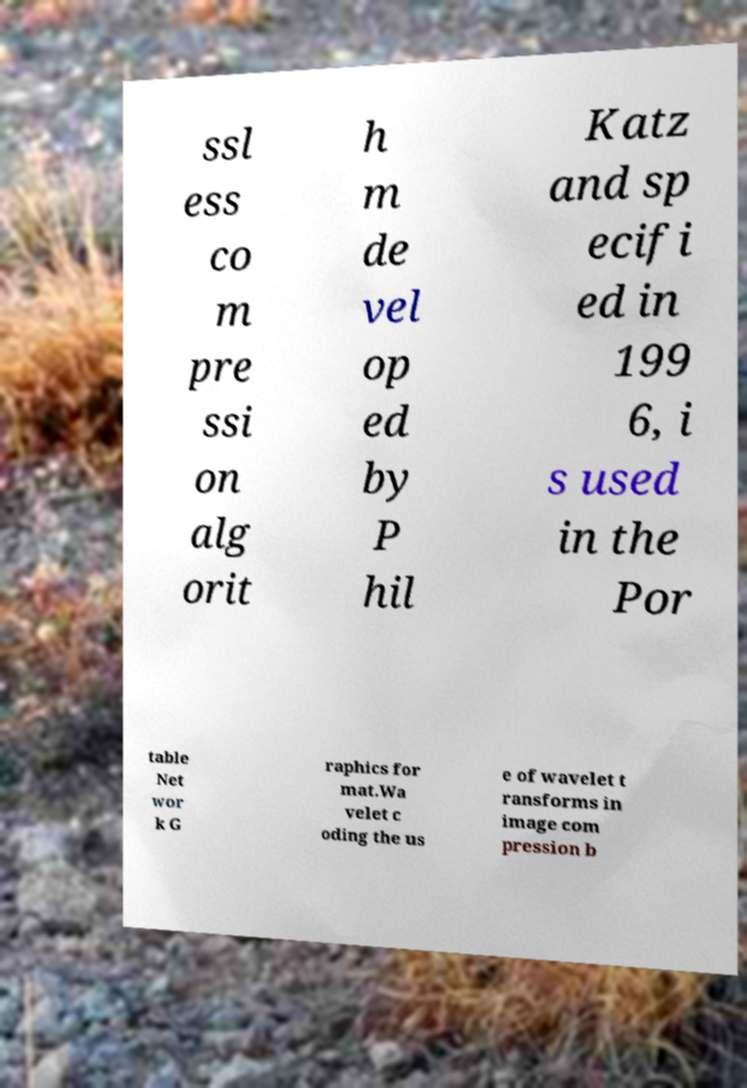I need the written content from this picture converted into text. Can you do that? ssl ess co m pre ssi on alg orit h m de vel op ed by P hil Katz and sp ecifi ed in 199 6, i s used in the Por table Net wor k G raphics for mat.Wa velet c oding the us e of wavelet t ransforms in image com pression b 